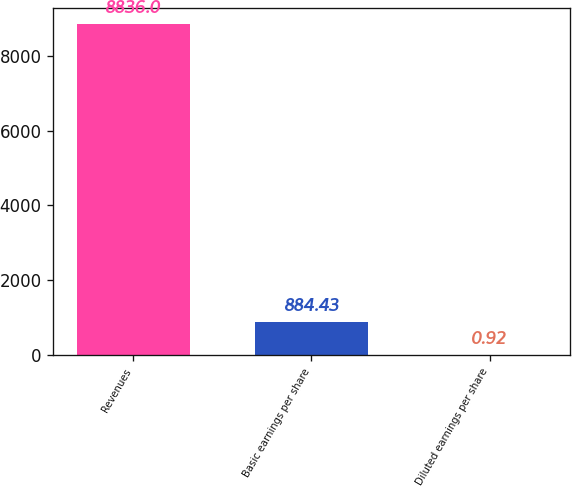Convert chart to OTSL. <chart><loc_0><loc_0><loc_500><loc_500><bar_chart><fcel>Revenues<fcel>Basic earnings per share<fcel>Diluted earnings per share<nl><fcel>8836<fcel>884.43<fcel>0.92<nl></chart> 